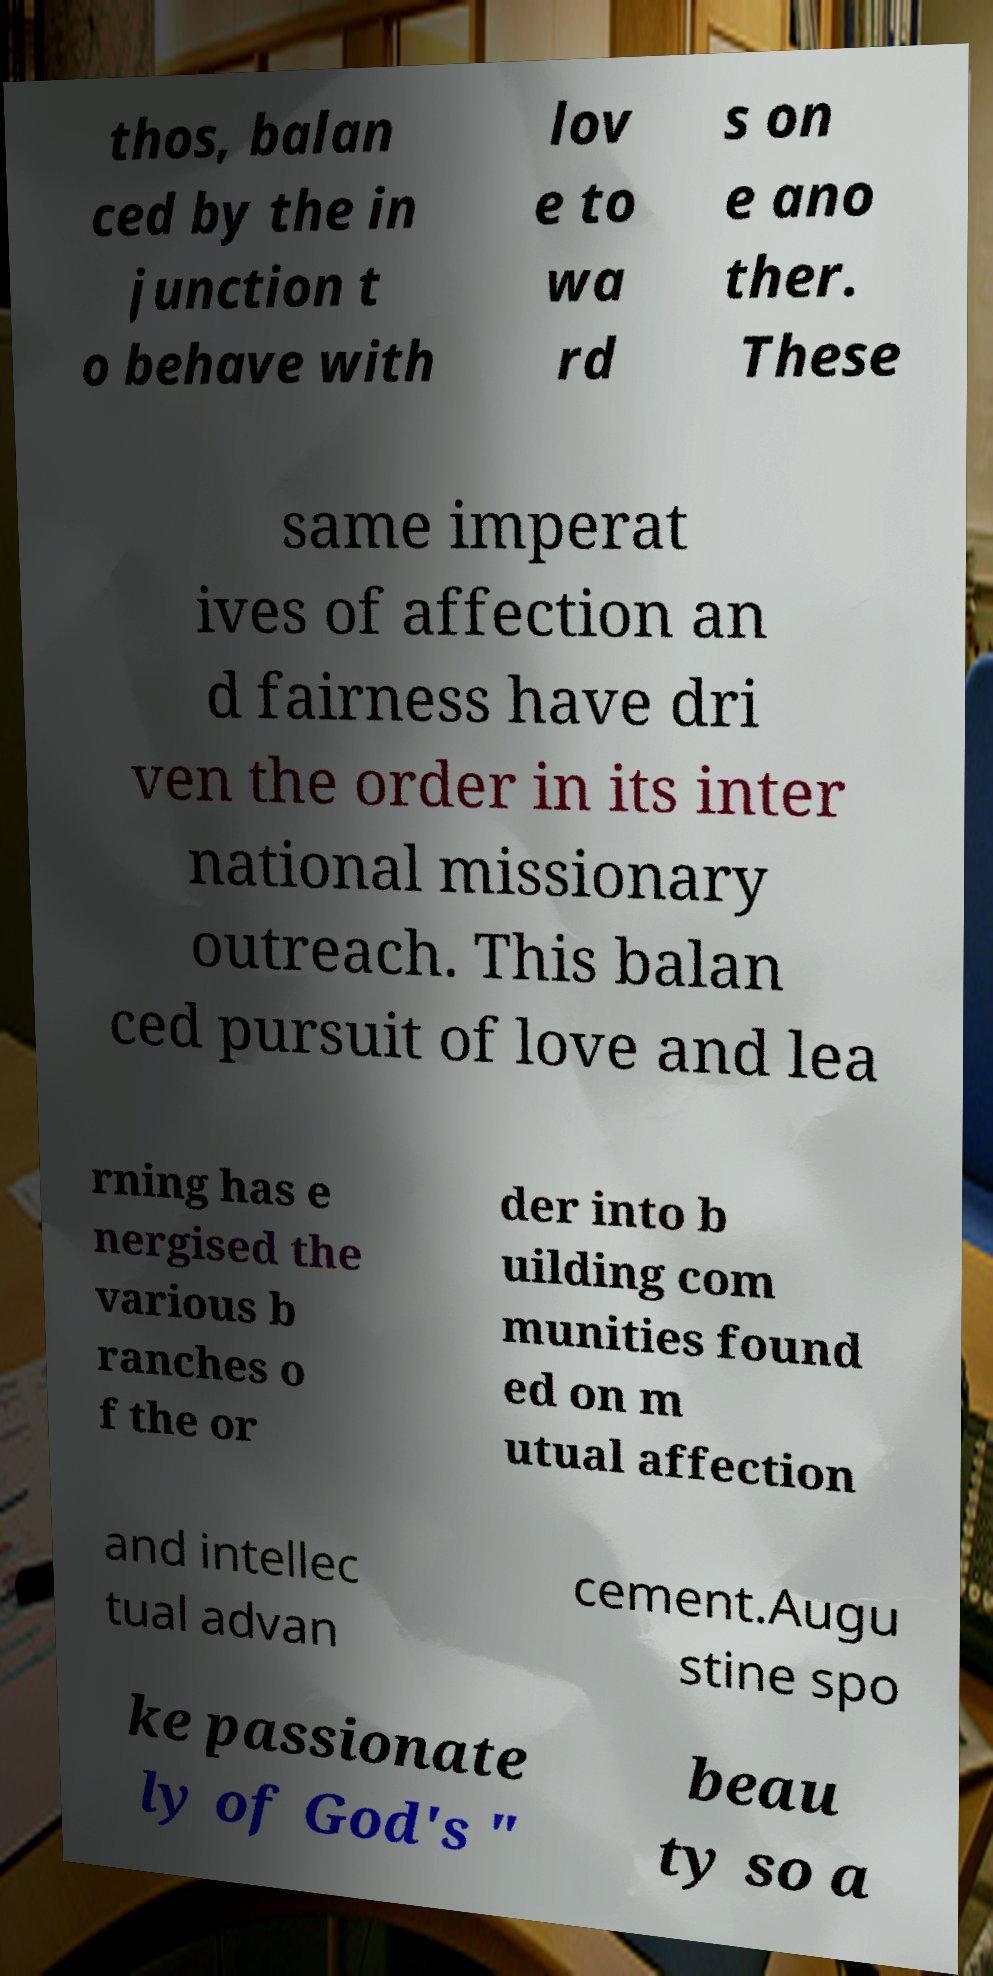Can you read and provide the text displayed in the image?This photo seems to have some interesting text. Can you extract and type it out for me? thos, balan ced by the in junction t o behave with lov e to wa rd s on e ano ther. These same imperat ives of affection an d fairness have dri ven the order in its inter national missionary outreach. This balan ced pursuit of love and lea rning has e nergised the various b ranches o f the or der into b uilding com munities found ed on m utual affection and intellec tual advan cement.Augu stine spo ke passionate ly of God's " beau ty so a 